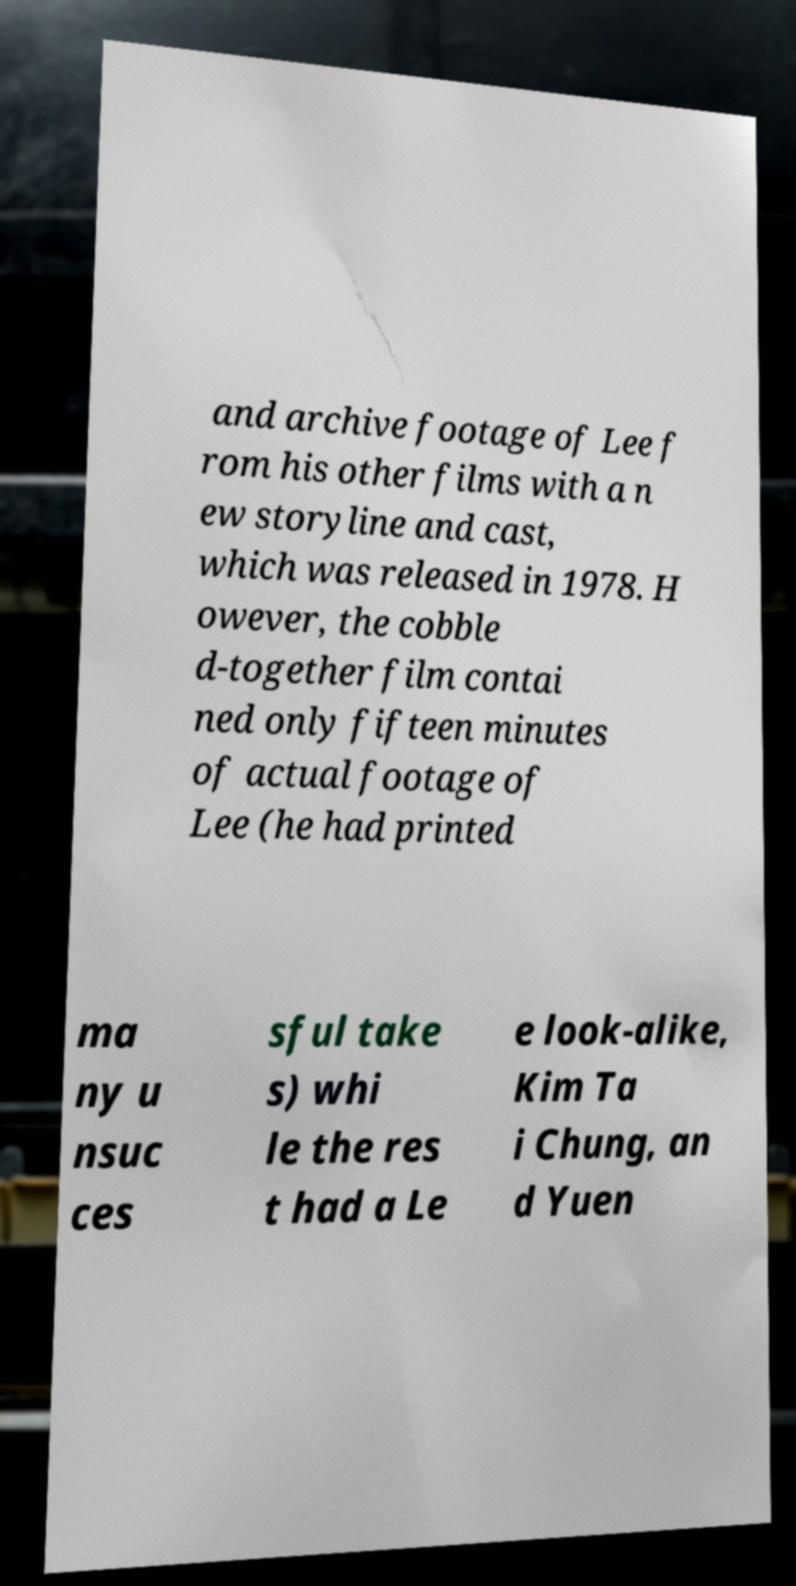Could you extract and type out the text from this image? and archive footage of Lee f rom his other films with a n ew storyline and cast, which was released in 1978. H owever, the cobble d-together film contai ned only fifteen minutes of actual footage of Lee (he had printed ma ny u nsuc ces sful take s) whi le the res t had a Le e look-alike, Kim Ta i Chung, an d Yuen 